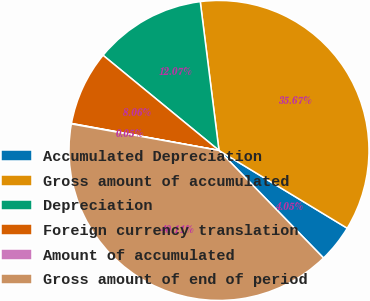Convert chart to OTSL. <chart><loc_0><loc_0><loc_500><loc_500><pie_chart><fcel>Accumulated Depreciation<fcel>Gross amount of accumulated<fcel>Depreciation<fcel>Foreign currency translation<fcel>Amount of accumulated<fcel>Gross amount of end of period<nl><fcel>4.05%<fcel>35.67%<fcel>12.07%<fcel>8.06%<fcel>0.05%<fcel>40.11%<nl></chart> 